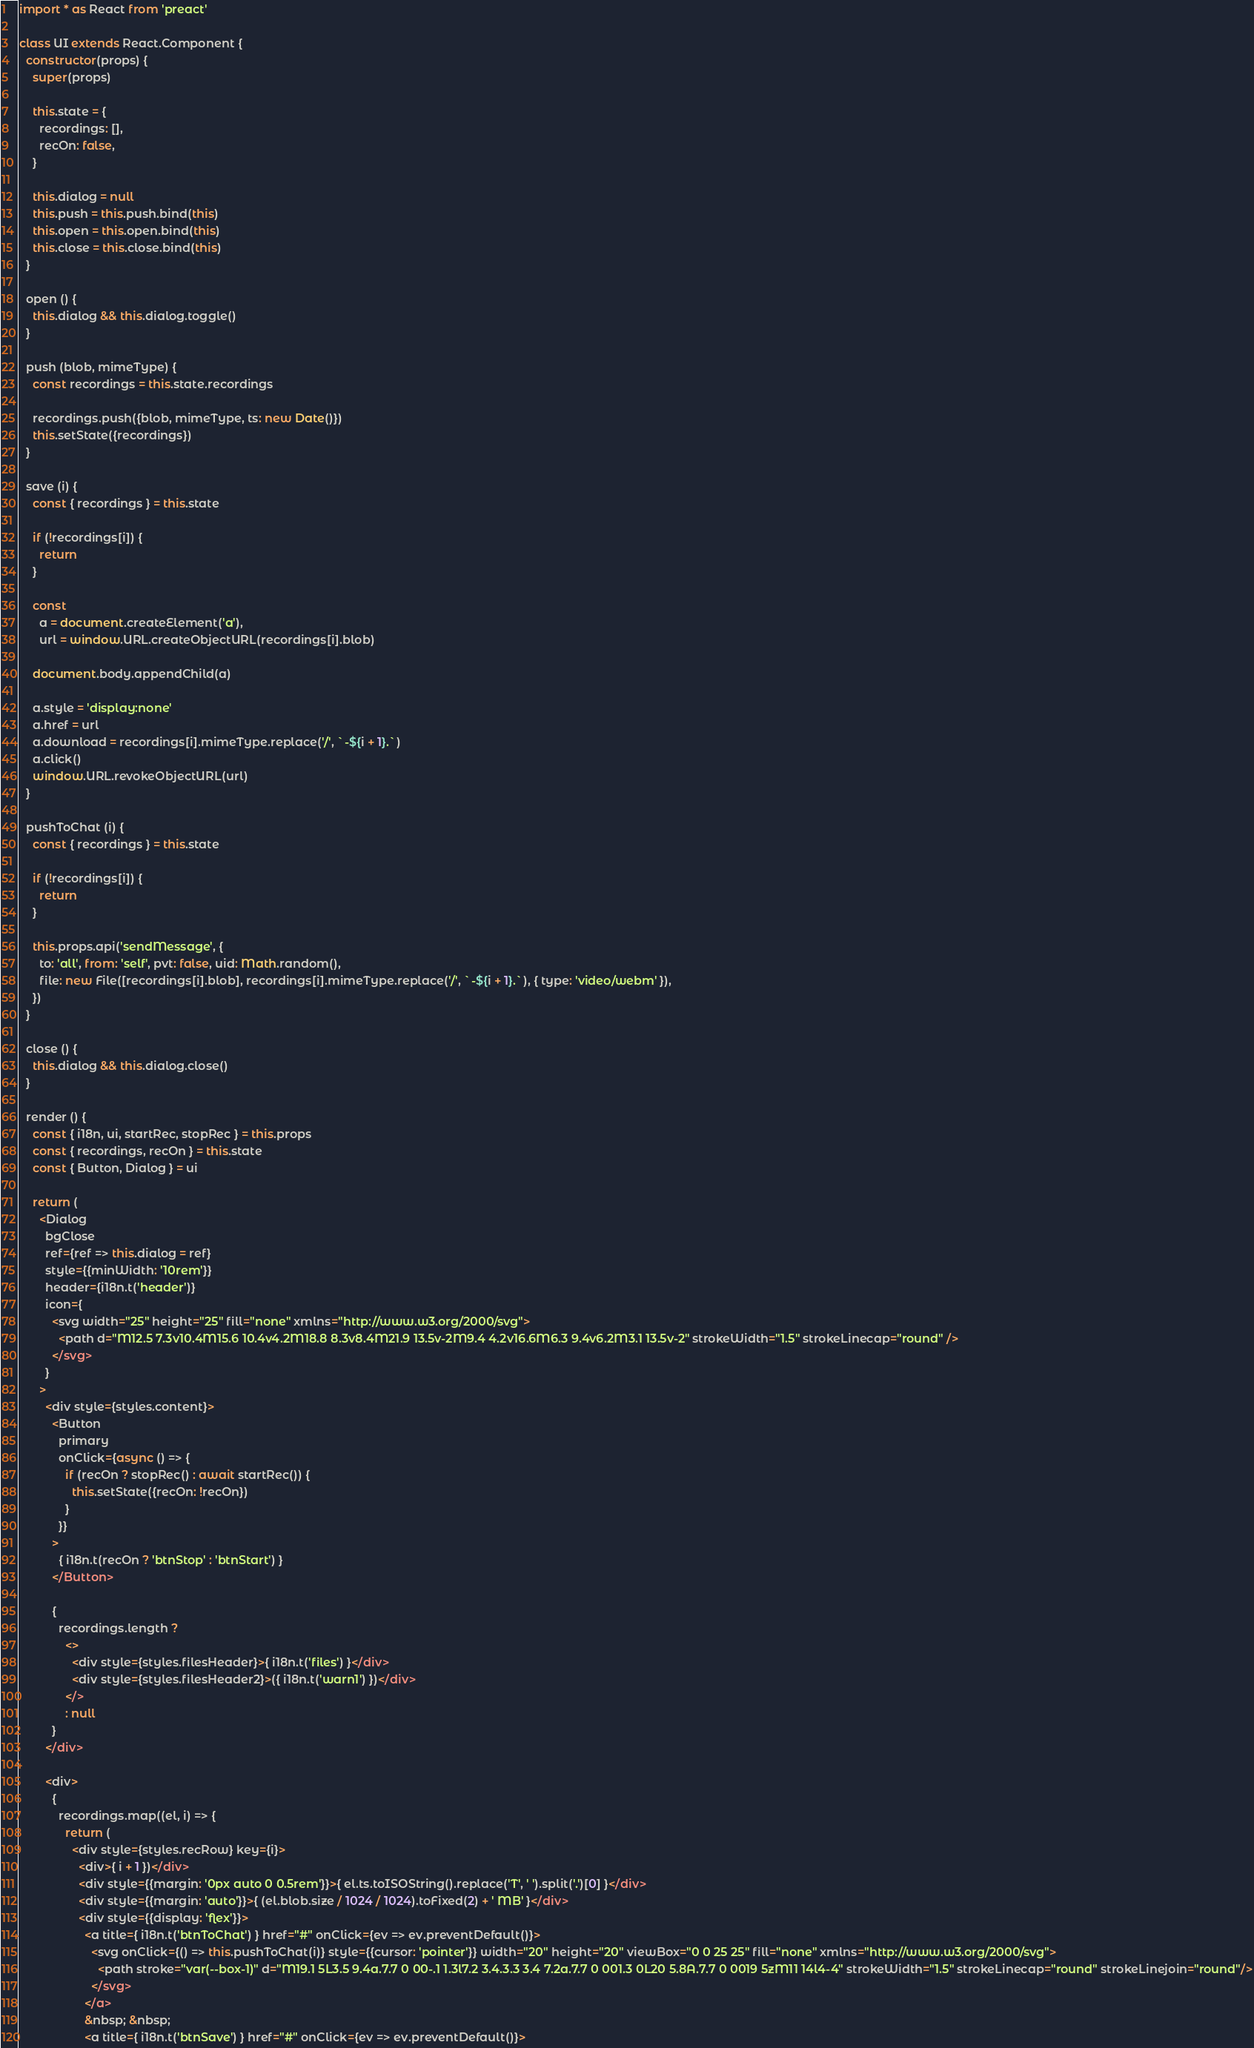<code> <loc_0><loc_0><loc_500><loc_500><_JavaScript_>import * as React from 'preact'

class UI extends React.Component {
  constructor(props) {
    super(props)

    this.state = {
      recordings: [],
      recOn: false,
    }

    this.dialog = null
    this.push = this.push.bind(this)
    this.open = this.open.bind(this)
    this.close = this.close.bind(this)
  }

  open () {
    this.dialog && this.dialog.toggle()
  }

  push (blob, mimeType) {
    const recordings = this.state.recordings

    recordings.push({blob, mimeType, ts: new Date()})
    this.setState({recordings})
  }

  save (i) {
    const { recordings } = this.state

    if (!recordings[i]) {
      return
    }

    const
      a = document.createElement('a'),
      url = window.URL.createObjectURL(recordings[i].blob)

    document.body.appendChild(a)

    a.style = 'display:none'
    a.href = url
    a.download = recordings[i].mimeType.replace('/', `-${i + 1}.`)
    a.click()
    window.URL.revokeObjectURL(url)
  }

  pushToChat (i) {
    const { recordings } = this.state

    if (!recordings[i]) {
      return
    }

    this.props.api('sendMessage', {
      to: 'all', from: 'self', pvt: false, uid: Math.random(),
      file: new File([recordings[i].blob], recordings[i].mimeType.replace('/', `-${i + 1}.`), { type: 'video/webm' }),
    })
  }

  close () {
    this.dialog && this.dialog.close()
  }

  render () {
    const { i18n, ui, startRec, stopRec } = this.props
    const { recordings, recOn } = this.state
    const { Button, Dialog } = ui

    return (
      <Dialog
        bgClose
        ref={ref => this.dialog = ref}
        style={{minWidth: '10rem'}}
        header={i18n.t('header')}
        icon={
          <svg width="25" height="25" fill="none" xmlns="http://www.w3.org/2000/svg">
            <path d="M12.5 7.3v10.4M15.6 10.4v4.2M18.8 8.3v8.4M21.9 13.5v-2M9.4 4.2v16.6M6.3 9.4v6.2M3.1 13.5v-2" strokeWidth="1.5" strokeLinecap="round" />
          </svg>
        }
      >
        <div style={styles.content}>
          <Button
            primary
            onClick={async () => {
              if (recOn ? stopRec() : await startRec()) {
                this.setState({recOn: !recOn})
              }
            }}
          >
            { i18n.t(recOn ? 'btnStop' : 'btnStart') }
          </Button>

          {
            recordings.length ?
              <>
                <div style={styles.filesHeader}>{ i18n.t('files') }</div>
                <div style={styles.filesHeader2}>({ i18n.t('warn1') })</div>
              </>
              : null
          }
        </div>

        <div>
          {
            recordings.map((el, i) => {
              return (
                <div style={styles.recRow} key={i}>
                  <div>{ i + 1 })</div>
                  <div style={{margin: '0px auto 0 0.5rem'}}>{ el.ts.toISOString().replace('T', ' ').split('.')[0] }</div>
                  <div style={{margin: 'auto'}}>{ (el.blob.size / 1024 / 1024).toFixed(2) + ' MB' }</div>
                  <div style={{display: 'flex'}}>
                    <a title={ i18n.t('btnToChat') } href="#" onClick={ev => ev.preventDefault()}>
                      <svg onClick={() => this.pushToChat(i)} style={{cursor: 'pointer'}} width="20" height="20" viewBox="0 0 25 25" fill="none" xmlns="http://www.w3.org/2000/svg">
                        <path stroke="var(--box-1)" d="M19.1 5L3.5 9.4a.7.7 0 00-.1 1.3l7.2 3.4.3.3 3.4 7.2a.7.7 0 001.3 0L20 5.8A.7.7 0 0019 5zM11 14l4-4" strokeWidth="1.5" strokeLinecap="round" strokeLinejoin="round"/>
                      </svg>
                    </a>
                    &nbsp; &nbsp;
                    <a title={ i18n.t('btnSave') } href="#" onClick={ev => ev.preventDefault()}></code> 